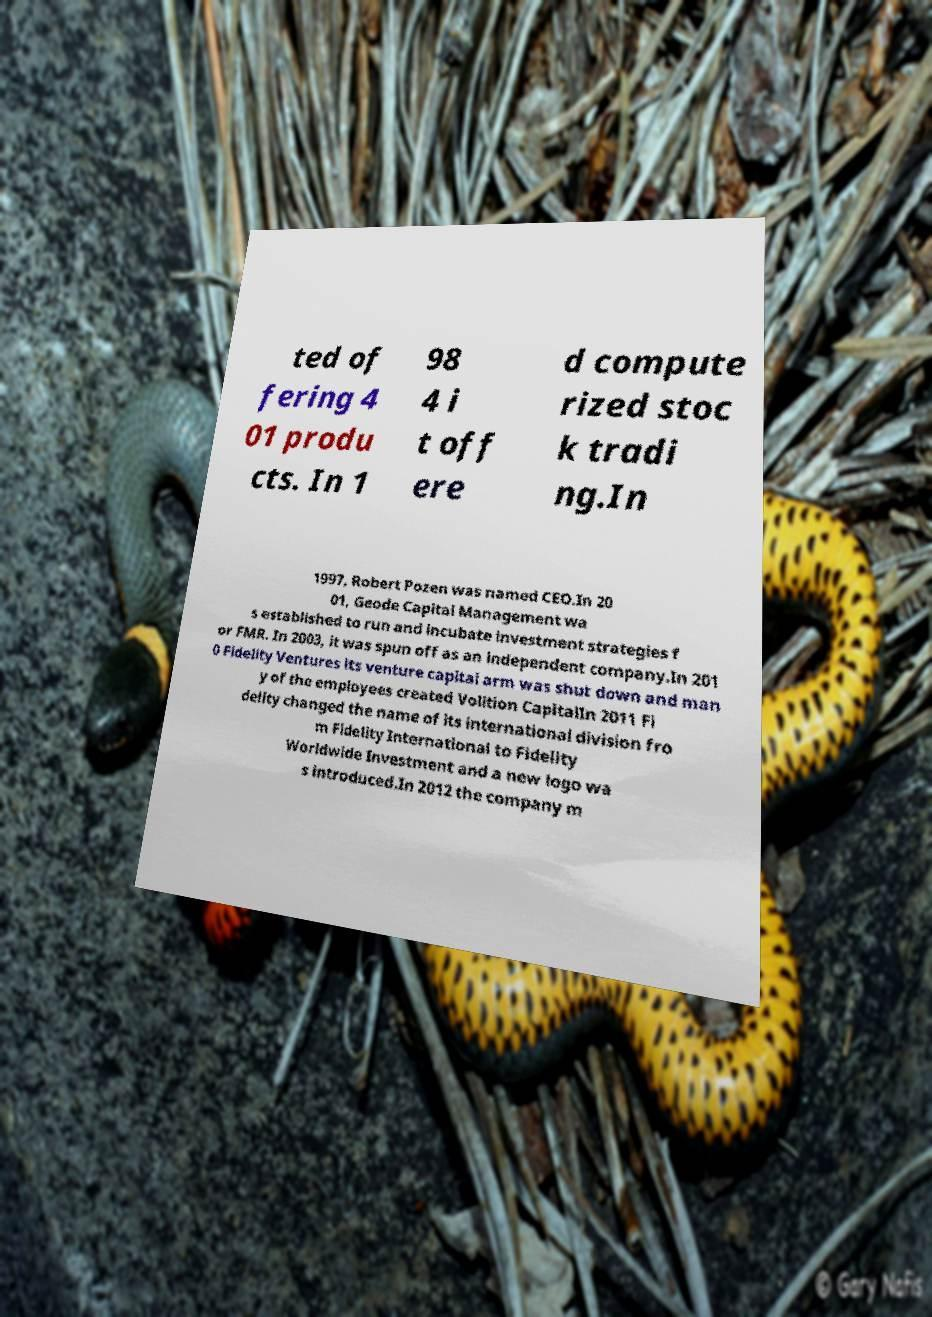There's text embedded in this image that I need extracted. Can you transcribe it verbatim? ted of fering 4 01 produ cts. In 1 98 4 i t off ere d compute rized stoc k tradi ng.In 1997, Robert Pozen was named CEO.In 20 01, Geode Capital Management wa s established to run and incubate investment strategies f or FMR. In 2003, it was spun off as an independent company.In 201 0 Fidelity Ventures its venture capital arm was shut down and man y of the employees created Volition CapitalIn 2011 Fi delity changed the name of its international division fro m Fidelity International to Fidelity Worldwide Investment and a new logo wa s introduced.In 2012 the company m 